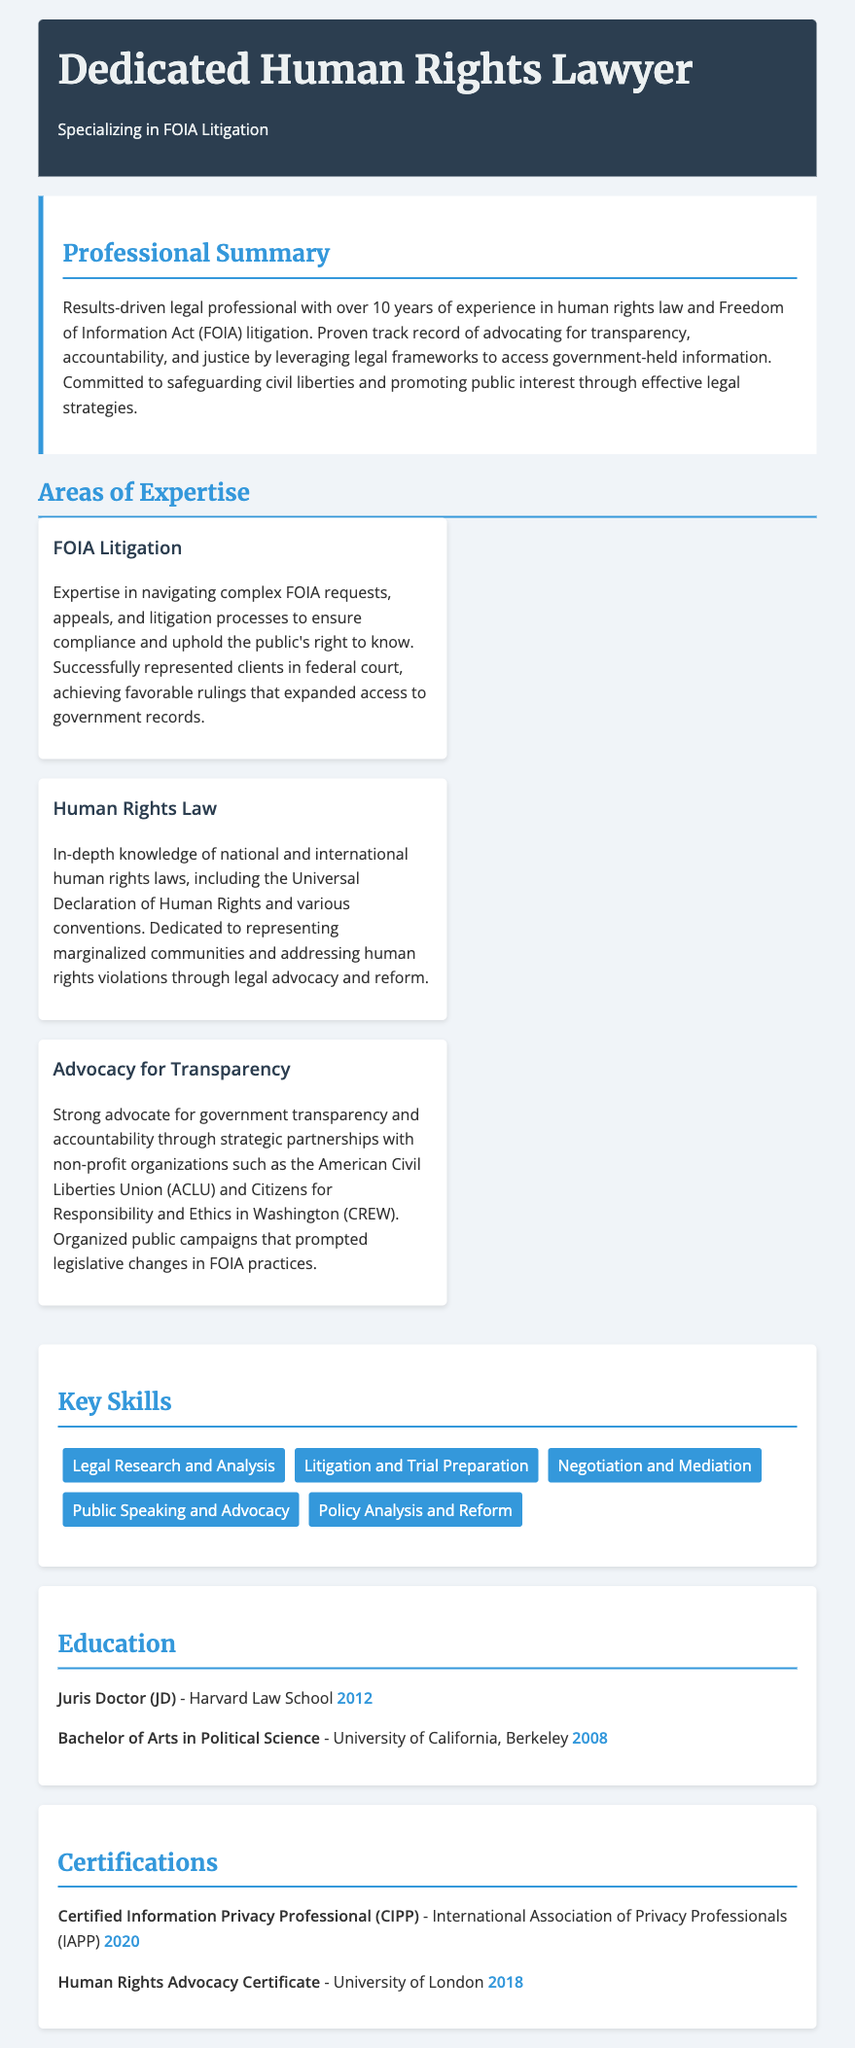What is the title of the resume? The title of the resume is indicated at the top, presenting the individual’s professional identity.
Answer: Dedicated Human Rights Lawyer What is the primary specialization mentioned? The professional summary highlights the main area of expertise for the lawyer.
Answer: FOIA Litigation How many years of experience does the lawyer have? The professional summary quantitatively describes the lawyer's experience in the field.
Answer: over 10 years What degree did the lawyer obtain from Harvard Law School? The education section lists the highest degree obtained by the lawyer along with the institution and year.
Answer: Juris Doctor (JD) Which organization is mentioned as a partner for transparency advocacy? The areas of expertise section highlights a specific organization involved in advocacy for transparency.
Answer: American Civil Liberties Union (ACLU) What certification was obtained in 2020? The certifications section provides details about various qualifications acquired by the lawyer, including the year.
Answer: Certified Information Privacy Professional (CIPP) What type of law does this lawyer dedicate themselves to? The professional summary emphasizes the focus of the lawyer’s legal practice.
Answer: human rights law How many key skills are listed in the resume? The key skills section enumerates the competencies of the lawyer.
Answer: five What university did the lawyer attend for their undergraduate degree? The education section gives the name of the institution where the lawyer earned their undergraduate degree.
Answer: University of California, Berkeley Which year did the lawyer receive the Human Rights Advocacy Certificate? The certifications section notes the year associated with the Human Rights Advocacy Certificate.
Answer: 2018 